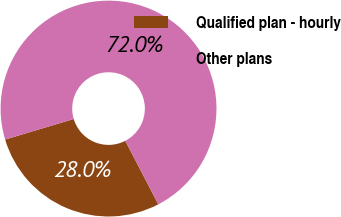Convert chart. <chart><loc_0><loc_0><loc_500><loc_500><pie_chart><fcel>Qualified plan - hourly<fcel>Other plans<nl><fcel>28.0%<fcel>72.0%<nl></chart> 